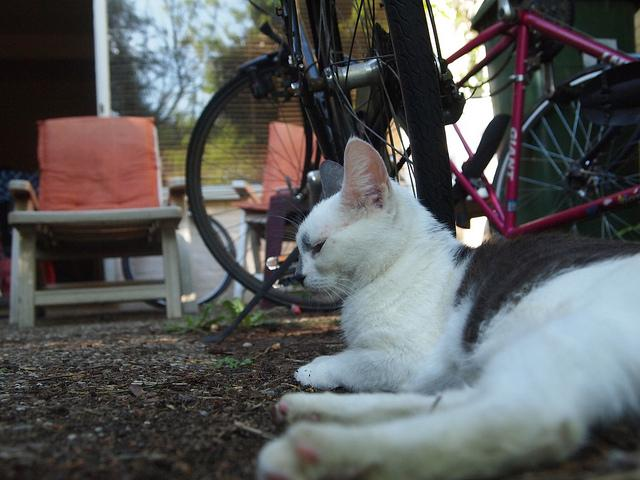What faces the most danger of getting hurt if people go to ride the bikes? cat 